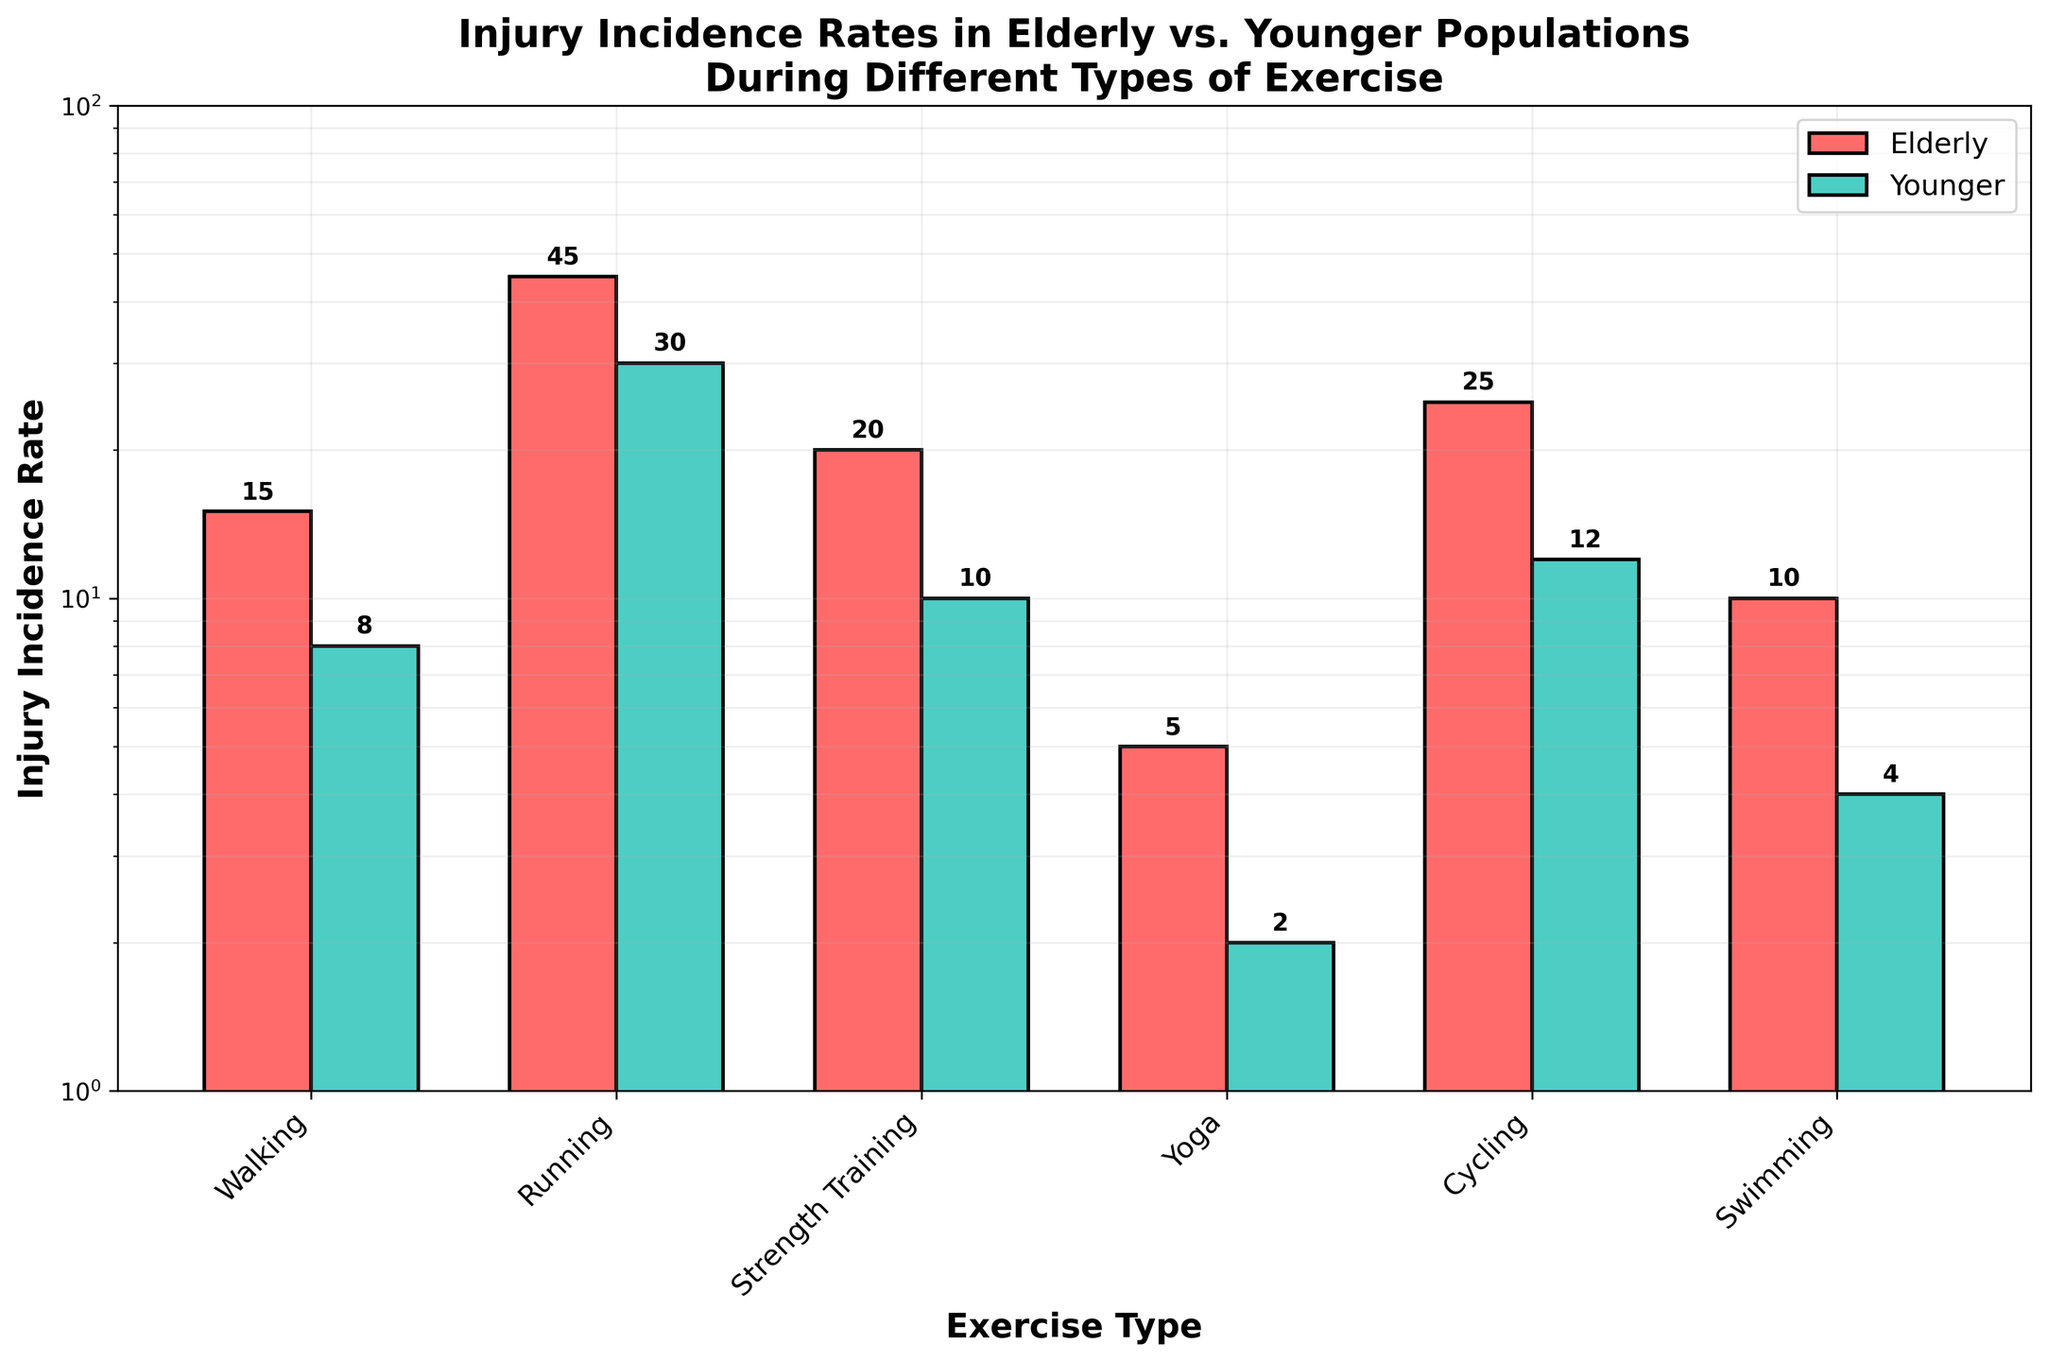What is the main title of the plot? The main title is displayed at the top of the plot, clearly stating the subject it visualizes.
Answer: Injury Incidence Rates in Elderly vs. Younger Populations During Different Types of Exercise What type of exercise has the highest injury incidence rate in elderly populations? By looking at the height of the bars for the elderly group, the exercise with the tallest bar represents the highest injury incidence rate.
Answer: Running How many exercise types are compared in the figure? By counting the number of distinct exercise labels on the x-axis, we can determine the number of exercise types compared.
Answer: Six Which age group has a higher injury incidence rate for swimming? Compare the height of the bars for swimming between the elderly and younger populations; the taller bar indicates the higher rate.
Answer: Elderly What is the injury incidence rate difference for cycling between the elderly and younger populations? Determine the height of the bars for cycling for both age groups, then subtract the younger group's rate from the elderly group's rate.
Answer: 13 Which type of exercise has the smallest difference in injury incidence rates between the two age groups? Calculate the injury incidence rate differences for each exercise and identify the smallest difference.
Answer: Yoga What is the sum of injury incidence rates for the elderly across all exercise types? Sum the heights of all bars representing the elderly population.
Answer: 120 Which type of exercise shows the largest relative increase in injury incidence rate when comparing the younger to the elderly population? Calculate the relative increase for each exercise type and identify the one with the largest value. Relative increase is calculated as (Elderly rate - Younger rate) / Younger rate * 100%.
Answer: Running What is the median injury incidence rate for the younger population across all exercises? Arrange the injury incidence rates for the younger population in ascending order and find the middle value. If the number of data points is even, the median is the average of the two central values.
Answer: 7 Is the injury incidence rate for walking in the elderly population greater than swimming in the younger population on a log scale? Compare the relative positions of the bars for walking in the elderly and swimming in the younger groups; if the walking bar is higher, then it is greater.
Answer: Yes 